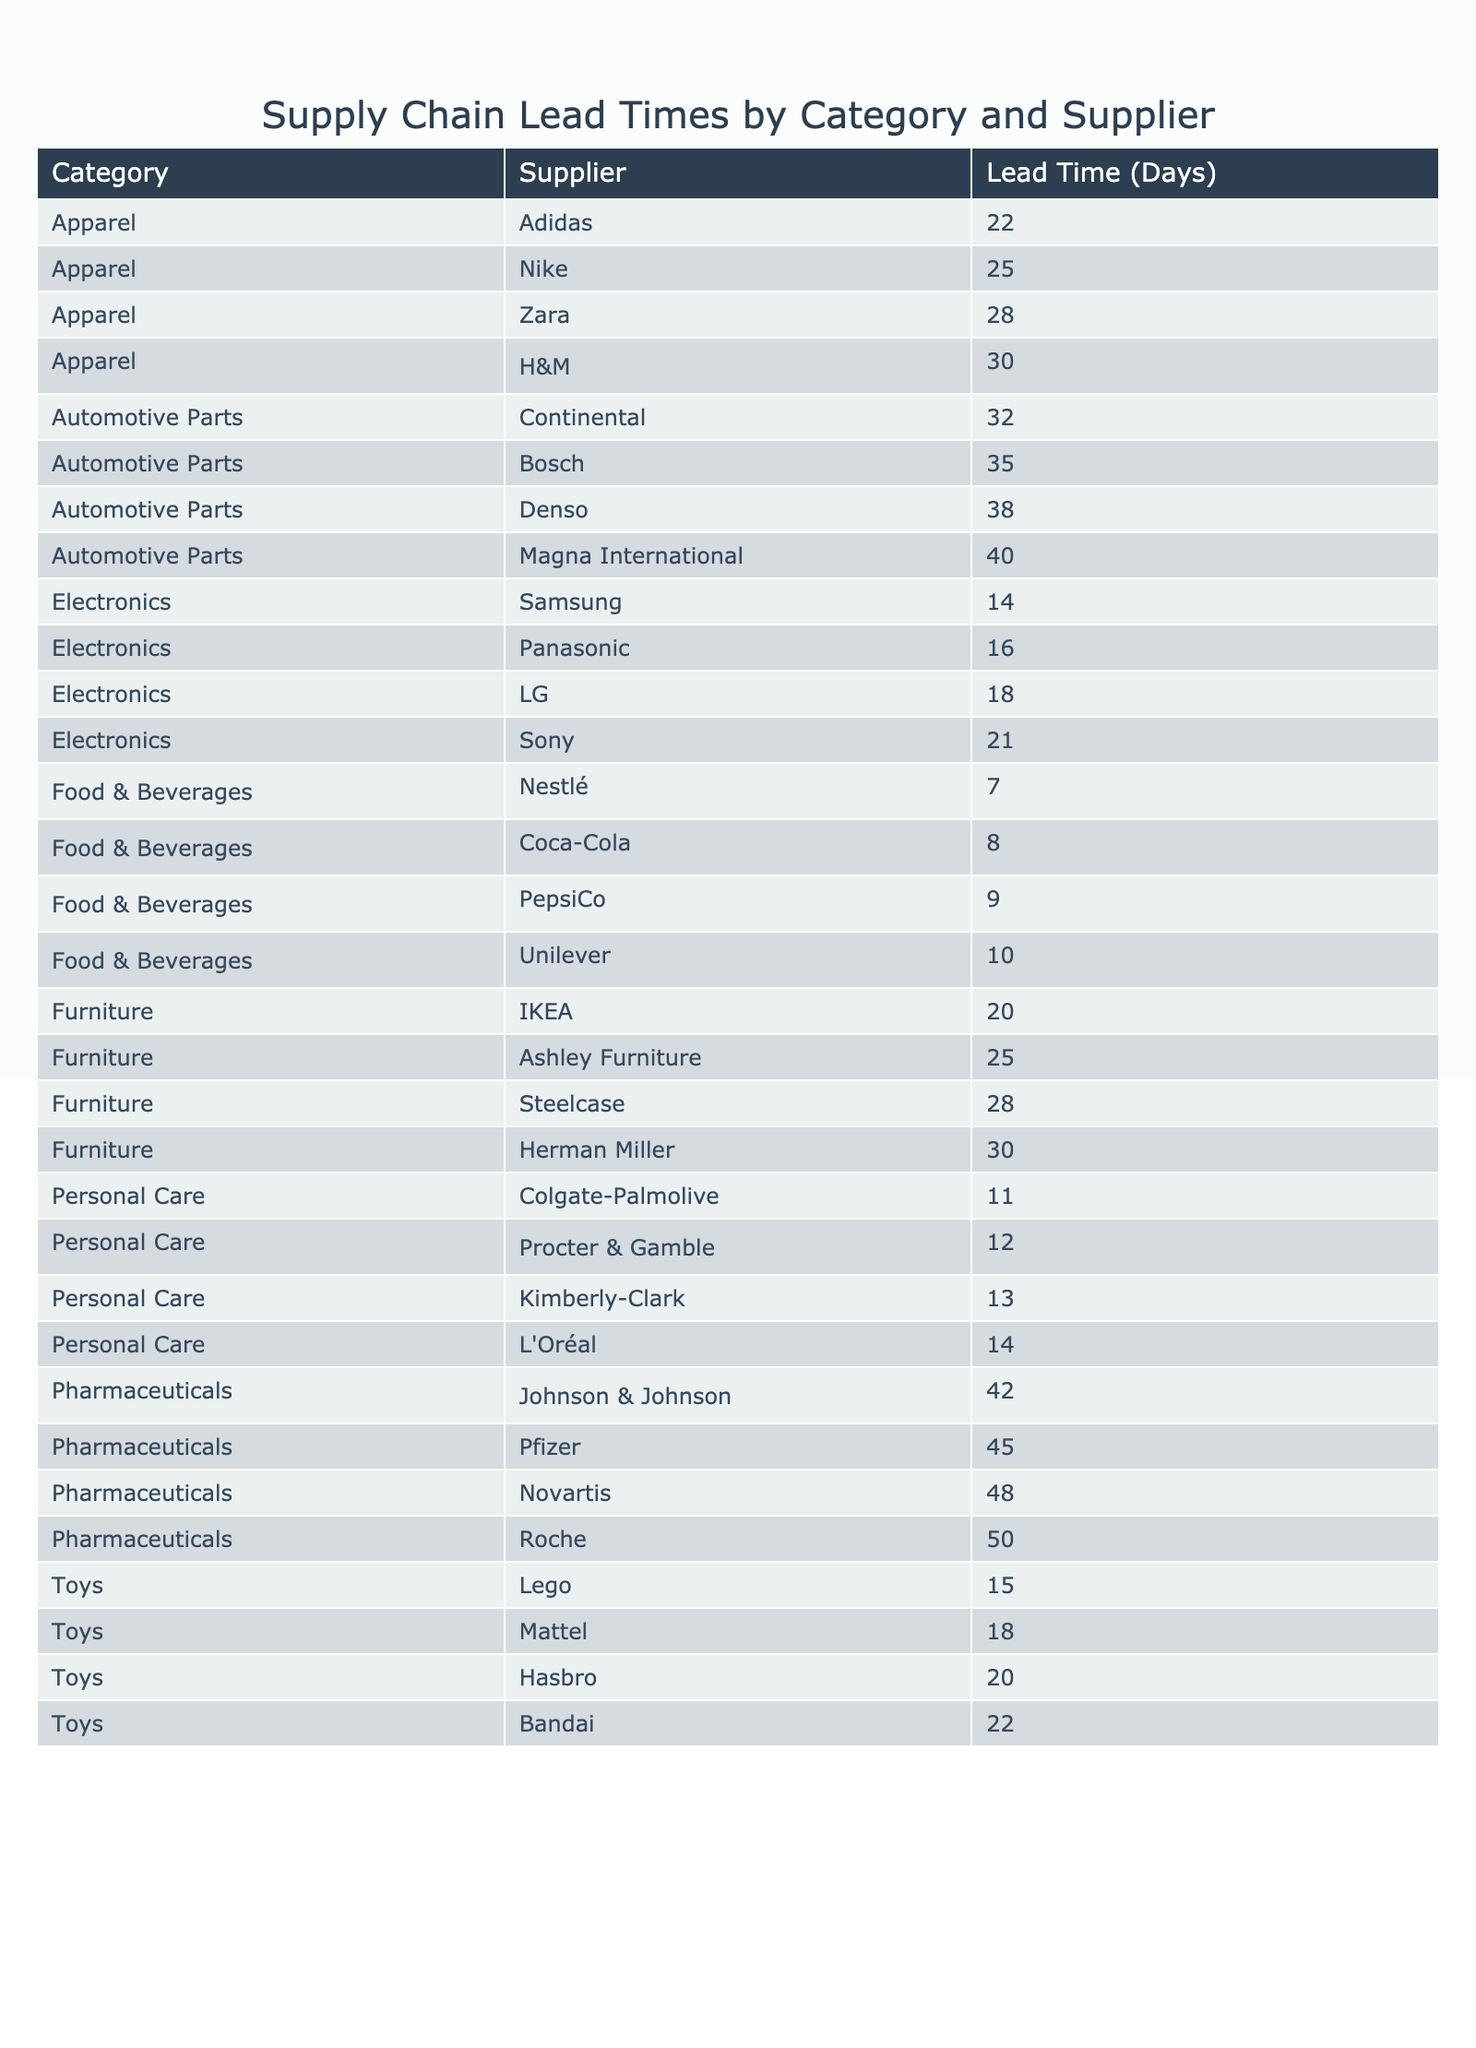What is the lead time for the supplier Nestlé in the Food & Beverages category? The table shows that Nestlé has a lead time of 7 days in the Food & Beverages category.
Answer: 7 days Which supplier has the longest lead time in the Pharmaceuticals category? The Pharmaceuticals category reveals that Roche has the longest lead time of 50 days, compared to Pfizer at 45 days, Johnson & Johnson at 42 days, and Novartis at 48 days.
Answer: Roche What is the average lead time for the Automotive Parts category? The Automotive Parts lead times are 35, 32, 38, and 40 days. Their sum is 35 + 32 + 38 + 40 = 145 days. Dividing by 4 leads to an average of 145 / 4 = 36.25 days.
Answer: 36.25 days Which product category has the shortest lead time? By comparing all the categories, the Food & Beverages category has the shortest lead time with Nestlé at 7 days.
Answer: Food & Beverages Is the average lead time for Electronics greater than that for Food & Beverages? The Electronics lead times are 14, 18, 21, and 16 days, which average to (14 + 18 + 21 + 16) / 4 = 17.25 days. The average for Food & Beverages is (7 + 9 + 8 + 10) / 4 = 8.5 days. Since 17.25 > 8.5, the statement is true.
Answer: Yes How many suppliers have a lead time of more than 30 days in the Apparel category? In the Apparel category, the lead times are 25, 22, 30, and 28 days. Only H&M at 30 days and Zara at 28 days do not exceed 30 days, while Nike at 25 and Adidas at 22 days are below. No suppliers in this category exceed 30 days.
Answer: 0 Which supplier in the Toys category has the second shortest lead time? The Toys category shows lead times of 15, 18, 20, and 22 days. Sorting these numbers gives: 15 (Lego), 18 (Mattel), 20 (Hasbro), and 22 (Bandai). Thus, Mattel has the second shortest lead time of 18 days.
Answer: Mattel What is the total lead time for all suppliers in the Personal Care category? The lead times for Personal Care are 12, 14, 11, and 13 days. Summing these provides: 12 + 14 + 11 + 13 = 50 days.
Answer: 50 days Are there any suppliers in the Furniture category with a lead time under 20 days? The Furniture category contains lead times of 20, 25, 28, and 30 days. None of these values are less than 20 days.
Answer: No Which category has the highest variation in lead time? To determine this, we look at the range of each category. The Pharmaceuticals category ranges from 42 to 50 days (difference of 8 days) and Automotive Parts from 35 to 40 days (5 days). The Apparel category ranges from 22 to 30 days (8 days). Since the highest difference occurs in Pharmaceuticals with a range of 8 days, it has the highest variation.
Answer: Pharmaceuticals 